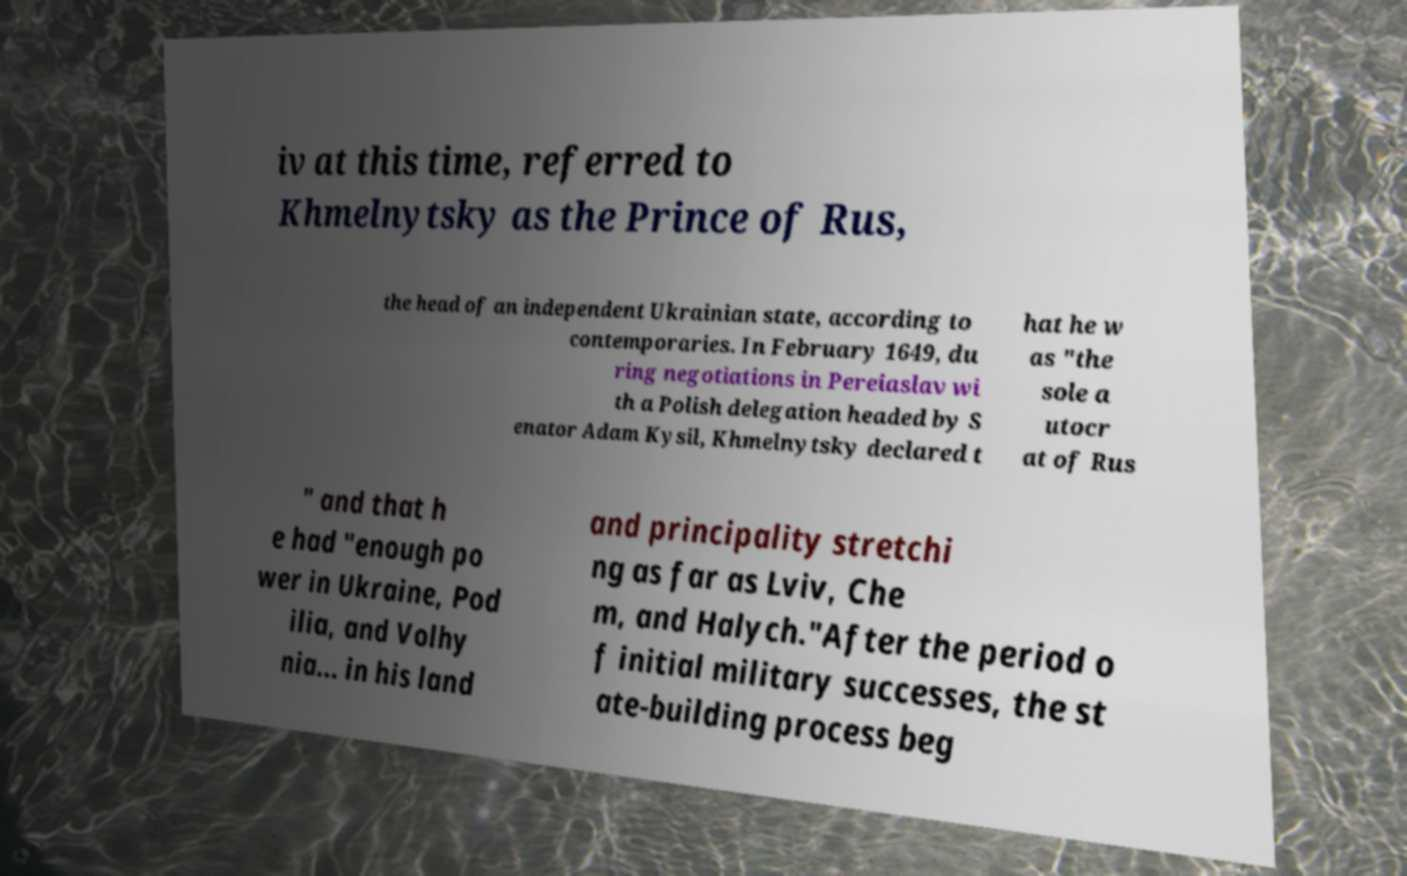Can you read and provide the text displayed in the image?This photo seems to have some interesting text. Can you extract and type it out for me? iv at this time, referred to Khmelnytsky as the Prince of Rus, the head of an independent Ukrainian state, according to contemporaries. In February 1649, du ring negotiations in Pereiaslav wi th a Polish delegation headed by S enator Adam Kysil, Khmelnytsky declared t hat he w as "the sole a utocr at of Rus " and that h e had "enough po wer in Ukraine, Pod ilia, and Volhy nia... in his land and principality stretchi ng as far as Lviv, Che m, and Halych."After the period o f initial military successes, the st ate-building process beg 